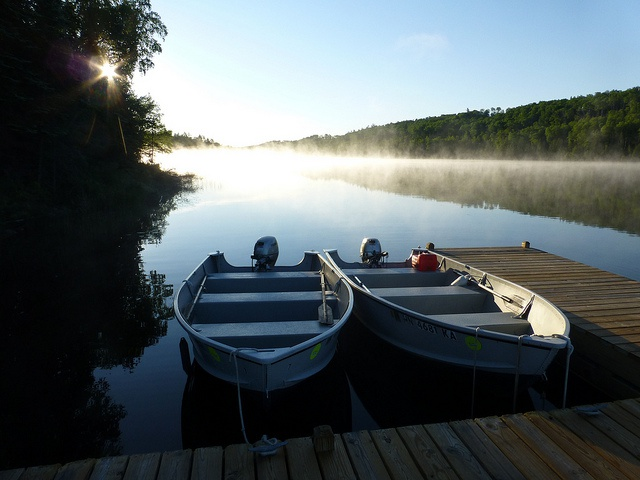Describe the objects in this image and their specific colors. I can see boat in black, gray, navy, and blue tones and boat in black, gray, and beige tones in this image. 